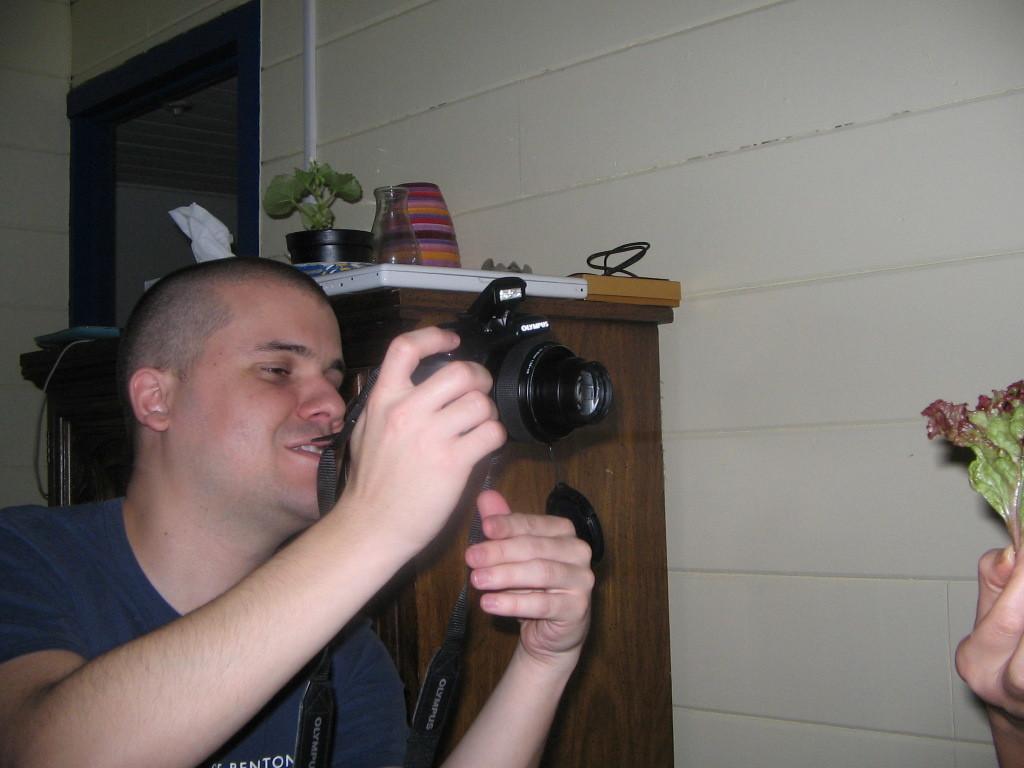Can you describe this image briefly? In this picture we can see a man and he is holding a camera in his hand besides to him we can find a flask, a bowl, a plant and a tray on the table and also we can find a wall. 